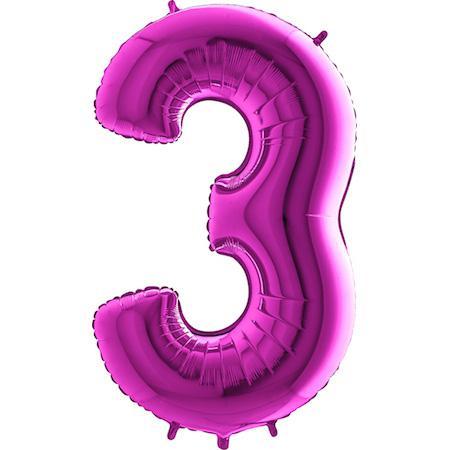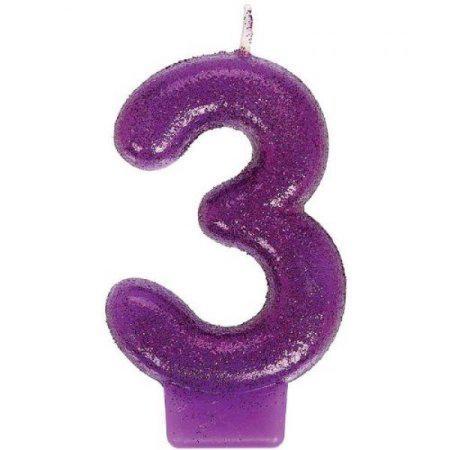The first image is the image on the left, the second image is the image on the right. Examine the images to the left and right. Is the description "Each image contains exactly one purple item shaped like the number three." accurate? Answer yes or no. Yes. The first image is the image on the left, the second image is the image on the right. Assess this claim about the two images: "All the number three balloons are blue.". Correct or not? Answer yes or no. No. 